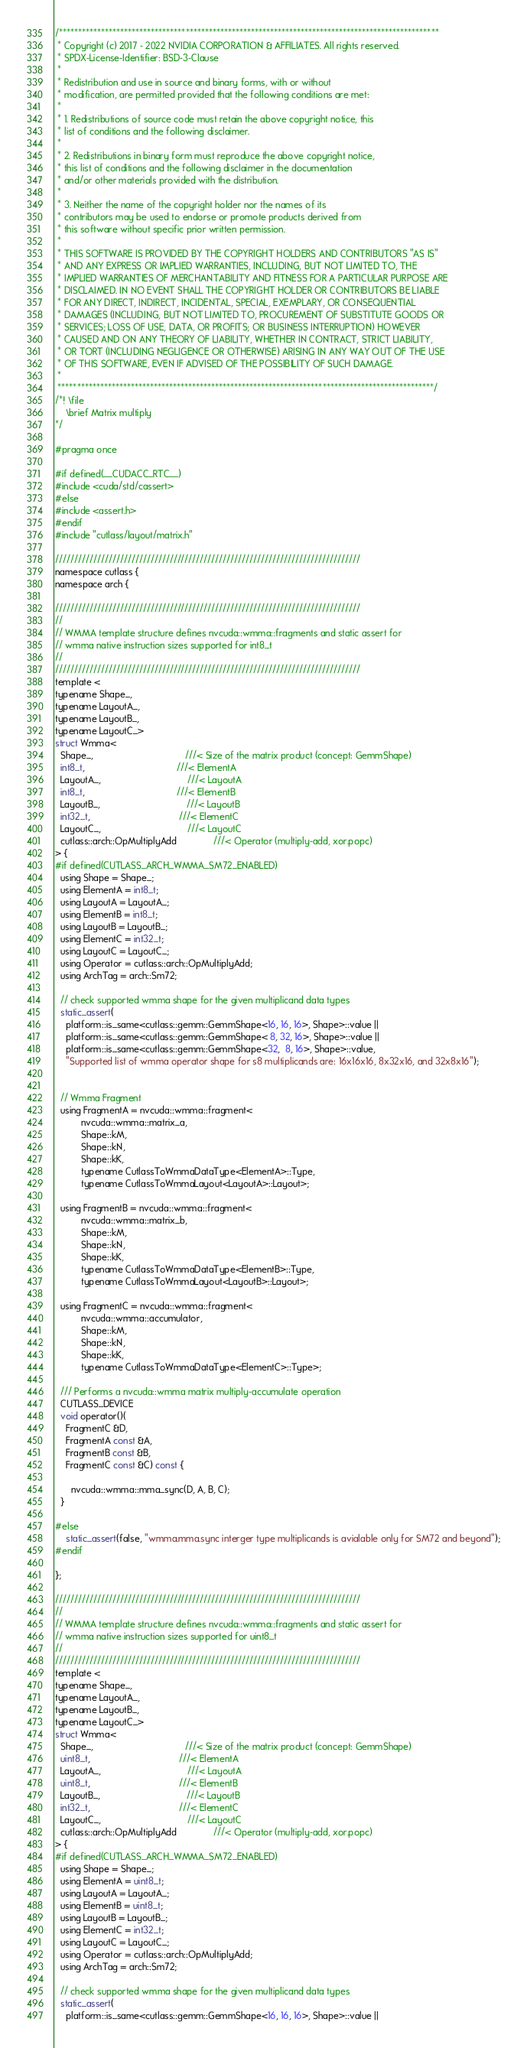Convert code to text. <code><loc_0><loc_0><loc_500><loc_500><_C_>/***************************************************************************************************
 * Copyright (c) 2017 - 2022 NVIDIA CORPORATION & AFFILIATES. All rights reserved.
 * SPDX-License-Identifier: BSD-3-Clause
 *
 * Redistribution and use in source and binary forms, with or without
 * modification, are permitted provided that the following conditions are met:
 *
 * 1. Redistributions of source code must retain the above copyright notice, this
 * list of conditions and the following disclaimer.
 *
 * 2. Redistributions in binary form must reproduce the above copyright notice,
 * this list of conditions and the following disclaimer in the documentation
 * and/or other materials provided with the distribution.
 *
 * 3. Neither the name of the copyright holder nor the names of its
 * contributors may be used to endorse or promote products derived from
 * this software without specific prior written permission.
 *
 * THIS SOFTWARE IS PROVIDED BY THE COPYRIGHT HOLDERS AND CONTRIBUTORS "AS IS"
 * AND ANY EXPRESS OR IMPLIED WARRANTIES, INCLUDING, BUT NOT LIMITED TO, THE
 * IMPLIED WARRANTIES OF MERCHANTABILITY AND FITNESS FOR A PARTICULAR PURPOSE ARE
 * DISCLAIMED. IN NO EVENT SHALL THE COPYRIGHT HOLDER OR CONTRIBUTORS BE LIABLE
 * FOR ANY DIRECT, INDIRECT, INCIDENTAL, SPECIAL, EXEMPLARY, OR CONSEQUENTIAL
 * DAMAGES (INCLUDING, BUT NOT LIMITED TO, PROCUREMENT OF SUBSTITUTE GOODS OR
 * SERVICES; LOSS OF USE, DATA, OR PROFITS; OR BUSINESS INTERRUPTION) HOWEVER
 * CAUSED AND ON ANY THEORY OF LIABILITY, WHETHER IN CONTRACT, STRICT LIABILITY,
 * OR TORT (INCLUDING NEGLIGENCE OR OTHERWISE) ARISING IN ANY WAY OUT OF THE USE
 * OF THIS SOFTWARE, EVEN IF ADVISED OF THE POSSIBILITY OF SUCH DAMAGE.
 *
 **************************************************************************************************/
/*! \file
    \brief Matrix multiply
*/

#pragma once

#if defined(__CUDACC_RTC__)
#include <cuda/std/cassert>
#else
#include <assert.h>
#endif
#include "cutlass/layout/matrix.h"

////////////////////////////////////////////////////////////////////////////////
namespace cutlass {
namespace arch {

////////////////////////////////////////////////////////////////////////////////
//
// WMMA template structure defines nvcuda::wmma::fragments and static assert for
// wmma native instruction sizes supported for int8_t
//
////////////////////////////////////////////////////////////////////////////////
template <
typename Shape_, 
typename LayoutA_, 
typename LayoutB_,
typename LayoutC_>
struct Wmma<
  Shape_,                                   ///< Size of the matrix product (concept: GemmShape)
  int8_t,                                   ///< ElementA
  LayoutA_,                                 ///< LayoutA
  int8_t,                                   ///< ElementB
  LayoutB_,                                 ///< LayoutB
  int32_t,                                  ///< ElementC
  LayoutC_,                                 ///< LayoutC
  cutlass::arch::OpMultiplyAdd              ///< Operator (multiply-add, xor.popc)
> {
#if defined(CUTLASS_ARCH_WMMA_SM72_ENABLED)
  using Shape = Shape_;
  using ElementA = int8_t;
  using LayoutA = LayoutA_;
  using ElementB = int8_t;
  using LayoutB = LayoutB_;
  using ElementC = int32_t;
  using LayoutC = LayoutC_;
  using Operator = cutlass::arch::OpMultiplyAdd;
  using ArchTag = arch::Sm72;

  // check supported wmma shape for the given multiplicand data types
  static_assert(
    platform::is_same<cutlass::gemm::GemmShape<16, 16, 16>, Shape>::value ||
    platform::is_same<cutlass::gemm::GemmShape< 8, 32, 16>, Shape>::value ||
    platform::is_same<cutlass::gemm::GemmShape<32,  8, 16>, Shape>::value,
    "Supported list of wmma operator shape for s8 multiplicands are: 16x16x16, 8x32x16, and 32x8x16");


  // Wmma Fragment
  using FragmentA = nvcuda::wmma::fragment<
          nvcuda::wmma::matrix_a,
          Shape::kM,
          Shape::kN,
          Shape::kK,
          typename CutlassToWmmaDataType<ElementA>::Type,
          typename CutlassToWmmaLayout<LayoutA>::Layout>;

  using FragmentB = nvcuda::wmma::fragment<
          nvcuda::wmma::matrix_b,
          Shape::kM,
          Shape::kN,
          Shape::kK,
          typename CutlassToWmmaDataType<ElementB>::Type,
          typename CutlassToWmmaLayout<LayoutB>::Layout>;

  using FragmentC = nvcuda::wmma::fragment<
          nvcuda::wmma::accumulator,
          Shape::kM,
          Shape::kN,
          Shape::kK,
          typename CutlassToWmmaDataType<ElementC>::Type>;

  /// Performs a nvcuda::wmma matrix multiply-accumulate operation
  CUTLASS_DEVICE
  void operator()(
    FragmentC &D, 
    FragmentA const &A, 
    FragmentB const &B, 
    FragmentC const &C) const {

      nvcuda::wmma::mma_sync(D, A, B, C);
  }

#else
    static_assert(false, "wmma.mma.sync interger type multiplicands is avialable only for SM72 and beyond");
#endif

};

////////////////////////////////////////////////////////////////////////////////
//
// WMMA template structure defines nvcuda::wmma::fragments and static assert for
// wmma native instruction sizes supported for uint8_t
//
////////////////////////////////////////////////////////////////////////////////
template <
typename Shape_, 
typename LayoutA_, 
typename LayoutB_,
typename LayoutC_>
struct Wmma<
  Shape_,                                   ///< Size of the matrix product (concept: GemmShape)
  uint8_t,                                  ///< ElementA
  LayoutA_,                                 ///< LayoutA
  uint8_t,                                  ///< ElementB
  LayoutB_,                                 ///< LayoutB
  int32_t,                                  ///< ElementC
  LayoutC_,                                 ///< LayoutC
  cutlass::arch::OpMultiplyAdd              ///< Operator (multiply-add, xor.popc)
> {
#if defined(CUTLASS_ARCH_WMMA_SM72_ENABLED)
  using Shape = Shape_;
  using ElementA = uint8_t;
  using LayoutA = LayoutA_;
  using ElementB = uint8_t;
  using LayoutB = LayoutB_;
  using ElementC = int32_t;
  using LayoutC = LayoutC_;
  using Operator = cutlass::arch::OpMultiplyAdd;
  using ArchTag = arch::Sm72;

  // check supported wmma shape for the given multiplicand data types
  static_assert(
    platform::is_same<cutlass::gemm::GemmShape<16, 16, 16>, Shape>::value ||</code> 